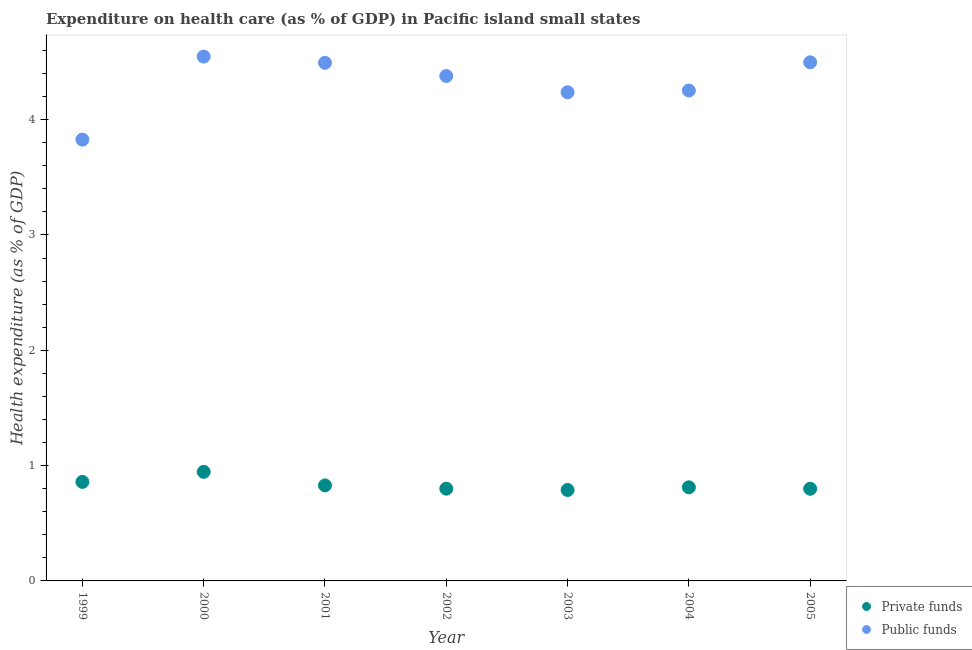How many different coloured dotlines are there?
Provide a succinct answer. 2. Is the number of dotlines equal to the number of legend labels?
Provide a succinct answer. Yes. What is the amount of private funds spent in healthcare in 1999?
Offer a terse response. 0.86. Across all years, what is the maximum amount of public funds spent in healthcare?
Your response must be concise. 4.55. Across all years, what is the minimum amount of public funds spent in healthcare?
Your answer should be very brief. 3.83. What is the total amount of private funds spent in healthcare in the graph?
Offer a terse response. 5.83. What is the difference between the amount of public funds spent in healthcare in 2003 and that in 2004?
Give a very brief answer. -0.02. What is the difference between the amount of public funds spent in healthcare in 2003 and the amount of private funds spent in healthcare in 2002?
Provide a succinct answer. 3.44. What is the average amount of public funds spent in healthcare per year?
Keep it short and to the point. 4.32. In the year 2003, what is the difference between the amount of public funds spent in healthcare and amount of private funds spent in healthcare?
Make the answer very short. 3.45. What is the ratio of the amount of private funds spent in healthcare in 2002 to that in 2003?
Your answer should be very brief. 1.01. Is the difference between the amount of private funds spent in healthcare in 1999 and 2004 greater than the difference between the amount of public funds spent in healthcare in 1999 and 2004?
Keep it short and to the point. Yes. What is the difference between the highest and the second highest amount of private funds spent in healthcare?
Ensure brevity in your answer.  0.09. What is the difference between the highest and the lowest amount of private funds spent in healthcare?
Provide a short and direct response. 0.16. Does the amount of private funds spent in healthcare monotonically increase over the years?
Provide a short and direct response. No. Is the amount of private funds spent in healthcare strictly less than the amount of public funds spent in healthcare over the years?
Your answer should be compact. Yes. What is the difference between two consecutive major ticks on the Y-axis?
Your answer should be compact. 1. Does the graph contain any zero values?
Provide a short and direct response. No. Does the graph contain grids?
Your answer should be very brief. No. Where does the legend appear in the graph?
Keep it short and to the point. Bottom right. How many legend labels are there?
Keep it short and to the point. 2. How are the legend labels stacked?
Ensure brevity in your answer.  Vertical. What is the title of the graph?
Your response must be concise. Expenditure on health care (as % of GDP) in Pacific island small states. Does "Lower secondary education" appear as one of the legend labels in the graph?
Give a very brief answer. No. What is the label or title of the X-axis?
Offer a very short reply. Year. What is the label or title of the Y-axis?
Your response must be concise. Health expenditure (as % of GDP). What is the Health expenditure (as % of GDP) in Private funds in 1999?
Keep it short and to the point. 0.86. What is the Health expenditure (as % of GDP) of Public funds in 1999?
Offer a terse response. 3.83. What is the Health expenditure (as % of GDP) of Private funds in 2000?
Make the answer very short. 0.95. What is the Health expenditure (as % of GDP) in Public funds in 2000?
Your answer should be compact. 4.55. What is the Health expenditure (as % of GDP) of Private funds in 2001?
Your answer should be very brief. 0.83. What is the Health expenditure (as % of GDP) of Public funds in 2001?
Offer a very short reply. 4.49. What is the Health expenditure (as % of GDP) of Private funds in 2002?
Offer a very short reply. 0.8. What is the Health expenditure (as % of GDP) of Public funds in 2002?
Provide a short and direct response. 4.38. What is the Health expenditure (as % of GDP) of Private funds in 2003?
Give a very brief answer. 0.79. What is the Health expenditure (as % of GDP) of Public funds in 2003?
Offer a terse response. 4.24. What is the Health expenditure (as % of GDP) of Private funds in 2004?
Provide a succinct answer. 0.81. What is the Health expenditure (as % of GDP) in Public funds in 2004?
Offer a very short reply. 4.25. What is the Health expenditure (as % of GDP) of Private funds in 2005?
Offer a terse response. 0.8. What is the Health expenditure (as % of GDP) in Public funds in 2005?
Keep it short and to the point. 4.5. Across all years, what is the maximum Health expenditure (as % of GDP) of Private funds?
Offer a very short reply. 0.95. Across all years, what is the maximum Health expenditure (as % of GDP) of Public funds?
Your answer should be compact. 4.55. Across all years, what is the minimum Health expenditure (as % of GDP) in Private funds?
Offer a very short reply. 0.79. Across all years, what is the minimum Health expenditure (as % of GDP) in Public funds?
Provide a succinct answer. 3.83. What is the total Health expenditure (as % of GDP) in Private funds in the graph?
Your response must be concise. 5.83. What is the total Health expenditure (as % of GDP) of Public funds in the graph?
Your answer should be compact. 30.23. What is the difference between the Health expenditure (as % of GDP) in Private funds in 1999 and that in 2000?
Your answer should be compact. -0.09. What is the difference between the Health expenditure (as % of GDP) of Public funds in 1999 and that in 2000?
Ensure brevity in your answer.  -0.72. What is the difference between the Health expenditure (as % of GDP) of Private funds in 1999 and that in 2001?
Ensure brevity in your answer.  0.03. What is the difference between the Health expenditure (as % of GDP) in Public funds in 1999 and that in 2001?
Offer a terse response. -0.67. What is the difference between the Health expenditure (as % of GDP) in Private funds in 1999 and that in 2002?
Your answer should be compact. 0.06. What is the difference between the Health expenditure (as % of GDP) of Public funds in 1999 and that in 2002?
Ensure brevity in your answer.  -0.55. What is the difference between the Health expenditure (as % of GDP) in Private funds in 1999 and that in 2003?
Make the answer very short. 0.07. What is the difference between the Health expenditure (as % of GDP) in Public funds in 1999 and that in 2003?
Offer a very short reply. -0.41. What is the difference between the Health expenditure (as % of GDP) of Private funds in 1999 and that in 2004?
Your answer should be compact. 0.05. What is the difference between the Health expenditure (as % of GDP) of Public funds in 1999 and that in 2004?
Provide a succinct answer. -0.43. What is the difference between the Health expenditure (as % of GDP) in Private funds in 1999 and that in 2005?
Provide a short and direct response. 0.06. What is the difference between the Health expenditure (as % of GDP) of Public funds in 1999 and that in 2005?
Your answer should be very brief. -0.67. What is the difference between the Health expenditure (as % of GDP) in Private funds in 2000 and that in 2001?
Keep it short and to the point. 0.12. What is the difference between the Health expenditure (as % of GDP) of Public funds in 2000 and that in 2001?
Provide a succinct answer. 0.05. What is the difference between the Health expenditure (as % of GDP) of Private funds in 2000 and that in 2002?
Keep it short and to the point. 0.15. What is the difference between the Health expenditure (as % of GDP) in Public funds in 2000 and that in 2002?
Keep it short and to the point. 0.17. What is the difference between the Health expenditure (as % of GDP) in Private funds in 2000 and that in 2003?
Make the answer very short. 0.16. What is the difference between the Health expenditure (as % of GDP) of Public funds in 2000 and that in 2003?
Offer a very short reply. 0.31. What is the difference between the Health expenditure (as % of GDP) of Private funds in 2000 and that in 2004?
Provide a short and direct response. 0.13. What is the difference between the Health expenditure (as % of GDP) of Public funds in 2000 and that in 2004?
Your response must be concise. 0.29. What is the difference between the Health expenditure (as % of GDP) in Private funds in 2000 and that in 2005?
Give a very brief answer. 0.15. What is the difference between the Health expenditure (as % of GDP) in Public funds in 2000 and that in 2005?
Offer a terse response. 0.05. What is the difference between the Health expenditure (as % of GDP) in Private funds in 2001 and that in 2002?
Give a very brief answer. 0.03. What is the difference between the Health expenditure (as % of GDP) of Public funds in 2001 and that in 2002?
Give a very brief answer. 0.11. What is the difference between the Health expenditure (as % of GDP) in Private funds in 2001 and that in 2003?
Your answer should be compact. 0.04. What is the difference between the Health expenditure (as % of GDP) of Public funds in 2001 and that in 2003?
Your answer should be very brief. 0.26. What is the difference between the Health expenditure (as % of GDP) in Private funds in 2001 and that in 2004?
Your answer should be very brief. 0.02. What is the difference between the Health expenditure (as % of GDP) in Public funds in 2001 and that in 2004?
Make the answer very short. 0.24. What is the difference between the Health expenditure (as % of GDP) of Private funds in 2001 and that in 2005?
Provide a succinct answer. 0.03. What is the difference between the Health expenditure (as % of GDP) in Public funds in 2001 and that in 2005?
Your answer should be very brief. -0. What is the difference between the Health expenditure (as % of GDP) of Private funds in 2002 and that in 2003?
Make the answer very short. 0.01. What is the difference between the Health expenditure (as % of GDP) in Public funds in 2002 and that in 2003?
Your answer should be very brief. 0.14. What is the difference between the Health expenditure (as % of GDP) in Private funds in 2002 and that in 2004?
Provide a succinct answer. -0.01. What is the difference between the Health expenditure (as % of GDP) in Public funds in 2002 and that in 2004?
Your response must be concise. 0.13. What is the difference between the Health expenditure (as % of GDP) of Private funds in 2002 and that in 2005?
Ensure brevity in your answer.  0. What is the difference between the Health expenditure (as % of GDP) of Public funds in 2002 and that in 2005?
Provide a short and direct response. -0.12. What is the difference between the Health expenditure (as % of GDP) of Private funds in 2003 and that in 2004?
Ensure brevity in your answer.  -0.02. What is the difference between the Health expenditure (as % of GDP) in Public funds in 2003 and that in 2004?
Give a very brief answer. -0.02. What is the difference between the Health expenditure (as % of GDP) of Private funds in 2003 and that in 2005?
Your answer should be very brief. -0.01. What is the difference between the Health expenditure (as % of GDP) in Public funds in 2003 and that in 2005?
Give a very brief answer. -0.26. What is the difference between the Health expenditure (as % of GDP) of Private funds in 2004 and that in 2005?
Ensure brevity in your answer.  0.01. What is the difference between the Health expenditure (as % of GDP) of Public funds in 2004 and that in 2005?
Provide a succinct answer. -0.24. What is the difference between the Health expenditure (as % of GDP) in Private funds in 1999 and the Health expenditure (as % of GDP) in Public funds in 2000?
Your response must be concise. -3.69. What is the difference between the Health expenditure (as % of GDP) of Private funds in 1999 and the Health expenditure (as % of GDP) of Public funds in 2001?
Your answer should be very brief. -3.63. What is the difference between the Health expenditure (as % of GDP) of Private funds in 1999 and the Health expenditure (as % of GDP) of Public funds in 2002?
Your answer should be compact. -3.52. What is the difference between the Health expenditure (as % of GDP) in Private funds in 1999 and the Health expenditure (as % of GDP) in Public funds in 2003?
Your response must be concise. -3.38. What is the difference between the Health expenditure (as % of GDP) in Private funds in 1999 and the Health expenditure (as % of GDP) in Public funds in 2004?
Your answer should be compact. -3.39. What is the difference between the Health expenditure (as % of GDP) of Private funds in 1999 and the Health expenditure (as % of GDP) of Public funds in 2005?
Keep it short and to the point. -3.64. What is the difference between the Health expenditure (as % of GDP) in Private funds in 2000 and the Health expenditure (as % of GDP) in Public funds in 2001?
Ensure brevity in your answer.  -3.55. What is the difference between the Health expenditure (as % of GDP) in Private funds in 2000 and the Health expenditure (as % of GDP) in Public funds in 2002?
Provide a succinct answer. -3.43. What is the difference between the Health expenditure (as % of GDP) in Private funds in 2000 and the Health expenditure (as % of GDP) in Public funds in 2003?
Your answer should be compact. -3.29. What is the difference between the Health expenditure (as % of GDP) in Private funds in 2000 and the Health expenditure (as % of GDP) in Public funds in 2004?
Your answer should be very brief. -3.31. What is the difference between the Health expenditure (as % of GDP) in Private funds in 2000 and the Health expenditure (as % of GDP) in Public funds in 2005?
Your answer should be very brief. -3.55. What is the difference between the Health expenditure (as % of GDP) of Private funds in 2001 and the Health expenditure (as % of GDP) of Public funds in 2002?
Offer a terse response. -3.55. What is the difference between the Health expenditure (as % of GDP) of Private funds in 2001 and the Health expenditure (as % of GDP) of Public funds in 2003?
Your answer should be very brief. -3.41. What is the difference between the Health expenditure (as % of GDP) in Private funds in 2001 and the Health expenditure (as % of GDP) in Public funds in 2004?
Provide a short and direct response. -3.42. What is the difference between the Health expenditure (as % of GDP) in Private funds in 2001 and the Health expenditure (as % of GDP) in Public funds in 2005?
Your answer should be compact. -3.67. What is the difference between the Health expenditure (as % of GDP) of Private funds in 2002 and the Health expenditure (as % of GDP) of Public funds in 2003?
Provide a succinct answer. -3.44. What is the difference between the Health expenditure (as % of GDP) of Private funds in 2002 and the Health expenditure (as % of GDP) of Public funds in 2004?
Offer a very short reply. -3.45. What is the difference between the Health expenditure (as % of GDP) in Private funds in 2002 and the Health expenditure (as % of GDP) in Public funds in 2005?
Your response must be concise. -3.7. What is the difference between the Health expenditure (as % of GDP) in Private funds in 2003 and the Health expenditure (as % of GDP) in Public funds in 2004?
Ensure brevity in your answer.  -3.46. What is the difference between the Health expenditure (as % of GDP) of Private funds in 2003 and the Health expenditure (as % of GDP) of Public funds in 2005?
Your answer should be very brief. -3.71. What is the difference between the Health expenditure (as % of GDP) of Private funds in 2004 and the Health expenditure (as % of GDP) of Public funds in 2005?
Ensure brevity in your answer.  -3.69. What is the average Health expenditure (as % of GDP) in Private funds per year?
Keep it short and to the point. 0.83. What is the average Health expenditure (as % of GDP) of Public funds per year?
Make the answer very short. 4.32. In the year 1999, what is the difference between the Health expenditure (as % of GDP) of Private funds and Health expenditure (as % of GDP) of Public funds?
Ensure brevity in your answer.  -2.97. In the year 2000, what is the difference between the Health expenditure (as % of GDP) of Private funds and Health expenditure (as % of GDP) of Public funds?
Ensure brevity in your answer.  -3.6. In the year 2001, what is the difference between the Health expenditure (as % of GDP) in Private funds and Health expenditure (as % of GDP) in Public funds?
Your response must be concise. -3.66. In the year 2002, what is the difference between the Health expenditure (as % of GDP) in Private funds and Health expenditure (as % of GDP) in Public funds?
Your answer should be compact. -3.58. In the year 2003, what is the difference between the Health expenditure (as % of GDP) of Private funds and Health expenditure (as % of GDP) of Public funds?
Your answer should be compact. -3.45. In the year 2004, what is the difference between the Health expenditure (as % of GDP) of Private funds and Health expenditure (as % of GDP) of Public funds?
Provide a short and direct response. -3.44. In the year 2005, what is the difference between the Health expenditure (as % of GDP) of Private funds and Health expenditure (as % of GDP) of Public funds?
Keep it short and to the point. -3.7. What is the ratio of the Health expenditure (as % of GDP) in Private funds in 1999 to that in 2000?
Offer a terse response. 0.91. What is the ratio of the Health expenditure (as % of GDP) in Public funds in 1999 to that in 2000?
Provide a short and direct response. 0.84. What is the ratio of the Health expenditure (as % of GDP) of Private funds in 1999 to that in 2001?
Give a very brief answer. 1.04. What is the ratio of the Health expenditure (as % of GDP) of Public funds in 1999 to that in 2001?
Your response must be concise. 0.85. What is the ratio of the Health expenditure (as % of GDP) of Private funds in 1999 to that in 2002?
Offer a terse response. 1.07. What is the ratio of the Health expenditure (as % of GDP) of Public funds in 1999 to that in 2002?
Provide a short and direct response. 0.87. What is the ratio of the Health expenditure (as % of GDP) in Private funds in 1999 to that in 2003?
Provide a short and direct response. 1.09. What is the ratio of the Health expenditure (as % of GDP) of Public funds in 1999 to that in 2003?
Offer a very short reply. 0.9. What is the ratio of the Health expenditure (as % of GDP) of Private funds in 1999 to that in 2004?
Provide a short and direct response. 1.06. What is the ratio of the Health expenditure (as % of GDP) in Public funds in 1999 to that in 2004?
Give a very brief answer. 0.9. What is the ratio of the Health expenditure (as % of GDP) of Private funds in 1999 to that in 2005?
Your response must be concise. 1.07. What is the ratio of the Health expenditure (as % of GDP) of Public funds in 1999 to that in 2005?
Provide a succinct answer. 0.85. What is the ratio of the Health expenditure (as % of GDP) of Private funds in 2000 to that in 2001?
Your response must be concise. 1.14. What is the ratio of the Health expenditure (as % of GDP) of Public funds in 2000 to that in 2001?
Your answer should be compact. 1.01. What is the ratio of the Health expenditure (as % of GDP) in Private funds in 2000 to that in 2002?
Provide a succinct answer. 1.18. What is the ratio of the Health expenditure (as % of GDP) in Private funds in 2000 to that in 2003?
Provide a short and direct response. 1.2. What is the ratio of the Health expenditure (as % of GDP) in Public funds in 2000 to that in 2003?
Your answer should be very brief. 1.07. What is the ratio of the Health expenditure (as % of GDP) of Private funds in 2000 to that in 2004?
Offer a very short reply. 1.17. What is the ratio of the Health expenditure (as % of GDP) of Public funds in 2000 to that in 2004?
Provide a succinct answer. 1.07. What is the ratio of the Health expenditure (as % of GDP) of Private funds in 2000 to that in 2005?
Make the answer very short. 1.18. What is the ratio of the Health expenditure (as % of GDP) in Public funds in 2000 to that in 2005?
Your response must be concise. 1.01. What is the ratio of the Health expenditure (as % of GDP) of Private funds in 2001 to that in 2002?
Give a very brief answer. 1.04. What is the ratio of the Health expenditure (as % of GDP) in Public funds in 2001 to that in 2002?
Offer a very short reply. 1.03. What is the ratio of the Health expenditure (as % of GDP) of Private funds in 2001 to that in 2003?
Your answer should be compact. 1.05. What is the ratio of the Health expenditure (as % of GDP) in Public funds in 2001 to that in 2003?
Keep it short and to the point. 1.06. What is the ratio of the Health expenditure (as % of GDP) of Private funds in 2001 to that in 2004?
Provide a short and direct response. 1.02. What is the ratio of the Health expenditure (as % of GDP) in Public funds in 2001 to that in 2004?
Your answer should be compact. 1.06. What is the ratio of the Health expenditure (as % of GDP) in Private funds in 2001 to that in 2005?
Ensure brevity in your answer.  1.04. What is the ratio of the Health expenditure (as % of GDP) of Public funds in 2001 to that in 2005?
Offer a terse response. 1. What is the ratio of the Health expenditure (as % of GDP) in Private funds in 2002 to that in 2003?
Keep it short and to the point. 1.01. What is the ratio of the Health expenditure (as % of GDP) in Public funds in 2002 to that in 2003?
Offer a terse response. 1.03. What is the ratio of the Health expenditure (as % of GDP) in Private funds in 2002 to that in 2004?
Offer a terse response. 0.99. What is the ratio of the Health expenditure (as % of GDP) in Public funds in 2002 to that in 2004?
Give a very brief answer. 1.03. What is the ratio of the Health expenditure (as % of GDP) of Public funds in 2002 to that in 2005?
Keep it short and to the point. 0.97. What is the ratio of the Health expenditure (as % of GDP) of Private funds in 2003 to that in 2004?
Provide a succinct answer. 0.97. What is the ratio of the Health expenditure (as % of GDP) of Public funds in 2003 to that in 2004?
Provide a short and direct response. 1. What is the ratio of the Health expenditure (as % of GDP) in Public funds in 2003 to that in 2005?
Offer a very short reply. 0.94. What is the ratio of the Health expenditure (as % of GDP) in Private funds in 2004 to that in 2005?
Your response must be concise. 1.02. What is the ratio of the Health expenditure (as % of GDP) of Public funds in 2004 to that in 2005?
Provide a succinct answer. 0.95. What is the difference between the highest and the second highest Health expenditure (as % of GDP) of Private funds?
Ensure brevity in your answer.  0.09. What is the difference between the highest and the second highest Health expenditure (as % of GDP) of Public funds?
Provide a short and direct response. 0.05. What is the difference between the highest and the lowest Health expenditure (as % of GDP) in Private funds?
Give a very brief answer. 0.16. What is the difference between the highest and the lowest Health expenditure (as % of GDP) in Public funds?
Your answer should be very brief. 0.72. 